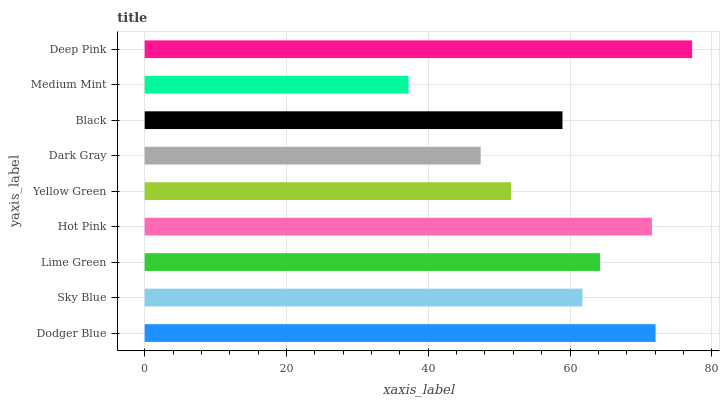Is Medium Mint the minimum?
Answer yes or no. Yes. Is Deep Pink the maximum?
Answer yes or no. Yes. Is Sky Blue the minimum?
Answer yes or no. No. Is Sky Blue the maximum?
Answer yes or no. No. Is Dodger Blue greater than Sky Blue?
Answer yes or no. Yes. Is Sky Blue less than Dodger Blue?
Answer yes or no. Yes. Is Sky Blue greater than Dodger Blue?
Answer yes or no. No. Is Dodger Blue less than Sky Blue?
Answer yes or no. No. Is Sky Blue the high median?
Answer yes or no. Yes. Is Sky Blue the low median?
Answer yes or no. Yes. Is Medium Mint the high median?
Answer yes or no. No. Is Medium Mint the low median?
Answer yes or no. No. 